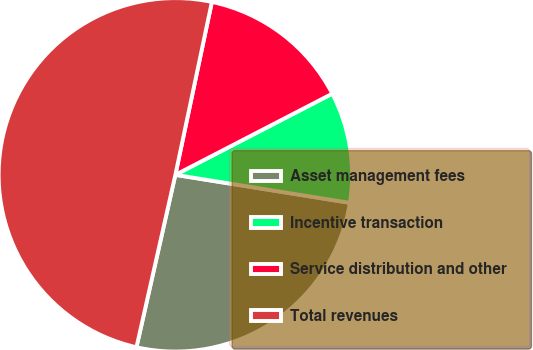Convert chart to OTSL. <chart><loc_0><loc_0><loc_500><loc_500><pie_chart><fcel>Asset management fees<fcel>Incentive transaction<fcel>Service distribution and other<fcel>Total revenues<nl><fcel>26.0%<fcel>10.13%<fcel>14.09%<fcel>49.78%<nl></chart> 